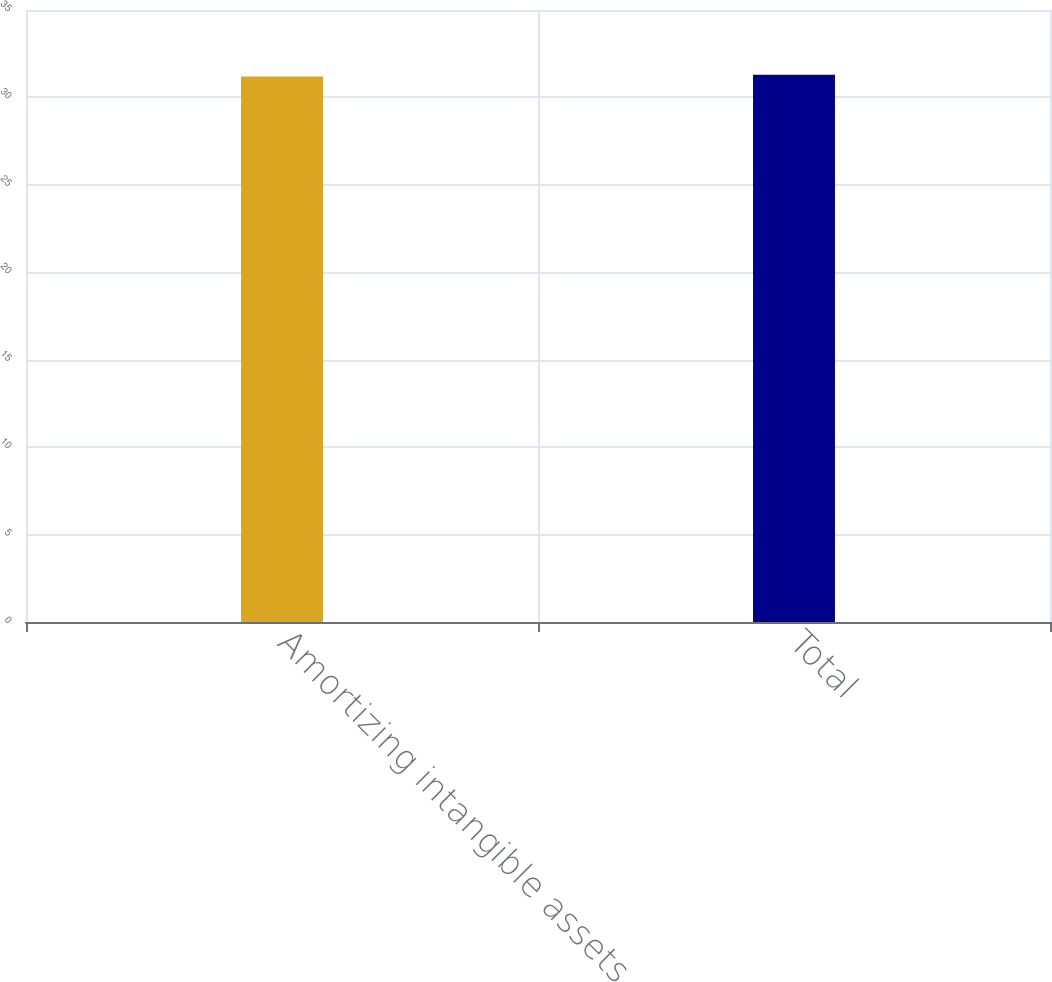Convert chart. <chart><loc_0><loc_0><loc_500><loc_500><bar_chart><fcel>Amortizing intangible assets<fcel>Total<nl><fcel>31.2<fcel>31.3<nl></chart> 